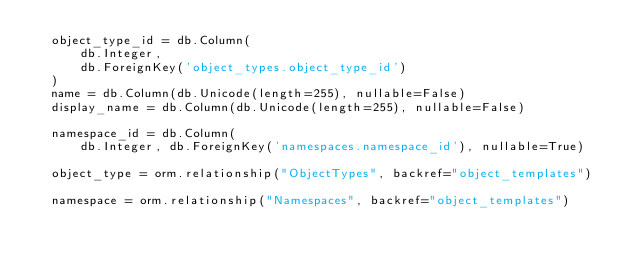Convert code to text. <code><loc_0><loc_0><loc_500><loc_500><_Python_>  object_type_id = db.Column(
      db.Integer,
      db.ForeignKey('object_types.object_type_id')
  )
  name = db.Column(db.Unicode(length=255), nullable=False)
  display_name = db.Column(db.Unicode(length=255), nullable=False)

  namespace_id = db.Column(
      db.Integer, db.ForeignKey('namespaces.namespace_id'), nullable=True)

  object_type = orm.relationship("ObjectTypes", backref="object_templates")

  namespace = orm.relationship("Namespaces", backref="object_templates")
</code> 